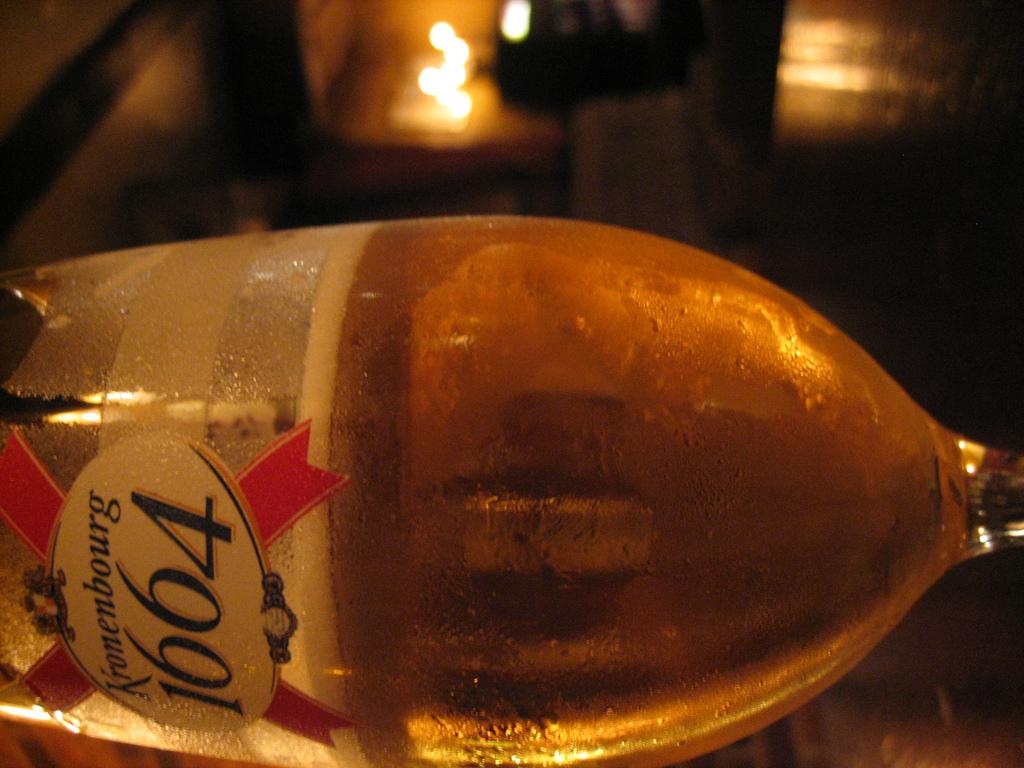What year is on the label?
Provide a succinct answer. 1664. What is the city named?
Ensure brevity in your answer.  Kronenbourg. 